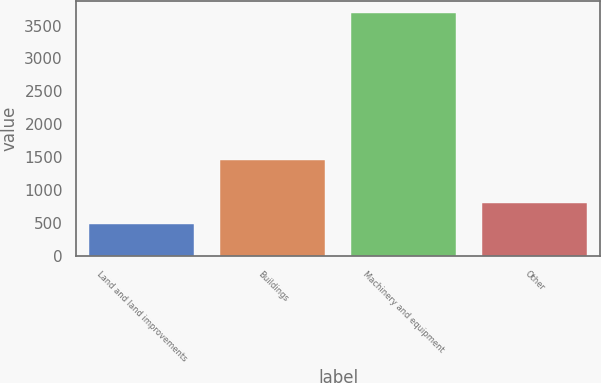Convert chart to OTSL. <chart><loc_0><loc_0><loc_500><loc_500><bar_chart><fcel>Land and land improvements<fcel>Buildings<fcel>Machinery and equipment<fcel>Other<nl><fcel>482<fcel>1453<fcel>3684<fcel>802.2<nl></chart> 